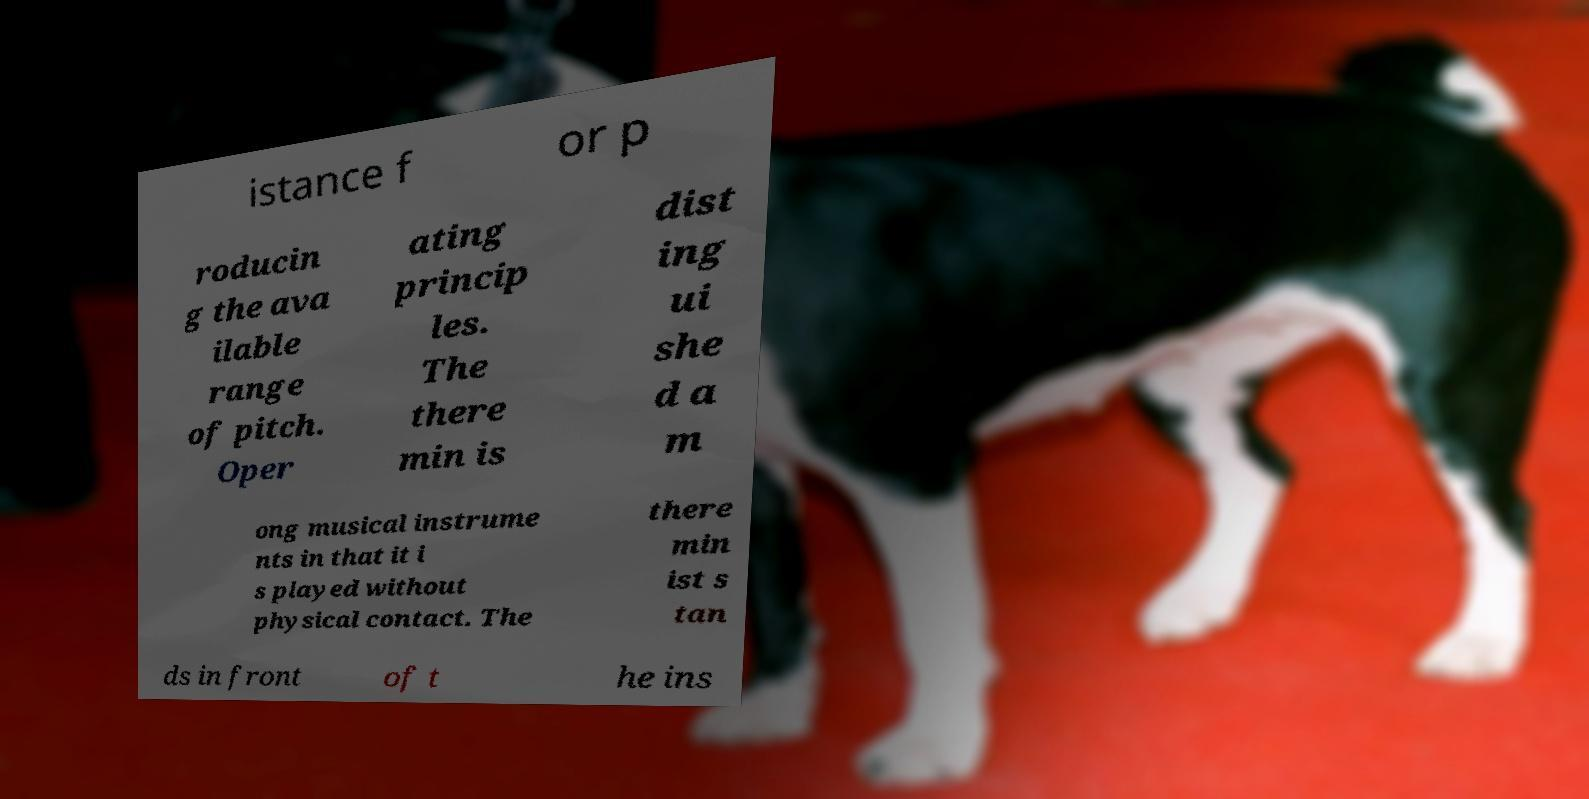For documentation purposes, I need the text within this image transcribed. Could you provide that? istance f or p roducin g the ava ilable range of pitch. Oper ating princip les. The there min is dist ing ui she d a m ong musical instrume nts in that it i s played without physical contact. The there min ist s tan ds in front of t he ins 